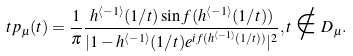Convert formula to latex. <formula><loc_0><loc_0><loc_500><loc_500>t p _ { \mu } ( t ) = \frac { 1 } { \pi } \frac { h ^ { \langle - 1 \rangle } ( 1 / t ) \sin f ( h ^ { \langle - 1 \rangle } ( 1 / t ) ) } { | 1 - h ^ { \langle - 1 \rangle } ( 1 / t ) e ^ { i f ( h ^ { \langle - 1 \rangle } ( 1 / t ) ) } | ^ { 2 } } , t \notin D _ { \mu } .</formula> 